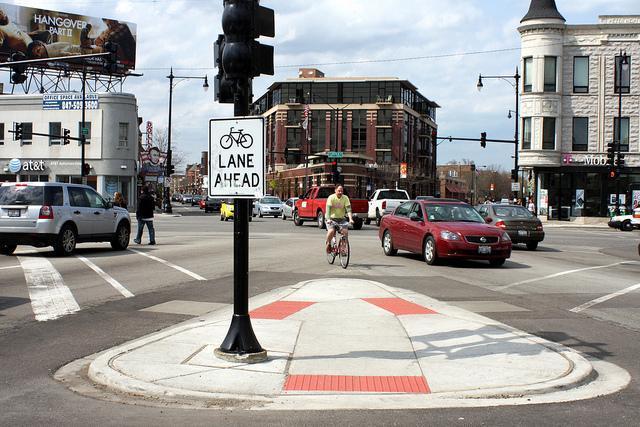How many cars can you see?
Give a very brief answer. 3. 